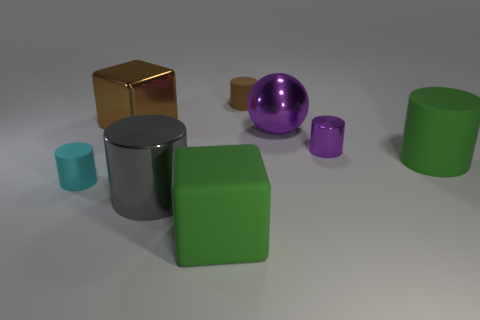Subtract all brown cylinders. How many cylinders are left? 4 Subtract all tiny brown matte cylinders. How many cylinders are left? 4 Subtract all blue cylinders. Subtract all brown blocks. How many cylinders are left? 5 Add 1 large gray metal cylinders. How many objects exist? 9 Subtract all cubes. How many objects are left? 6 Add 4 large blue cylinders. How many large blue cylinders exist? 4 Subtract 0 blue blocks. How many objects are left? 8 Subtract all gray metallic cylinders. Subtract all big cyan rubber cylinders. How many objects are left? 7 Add 8 brown matte cylinders. How many brown matte cylinders are left? 9 